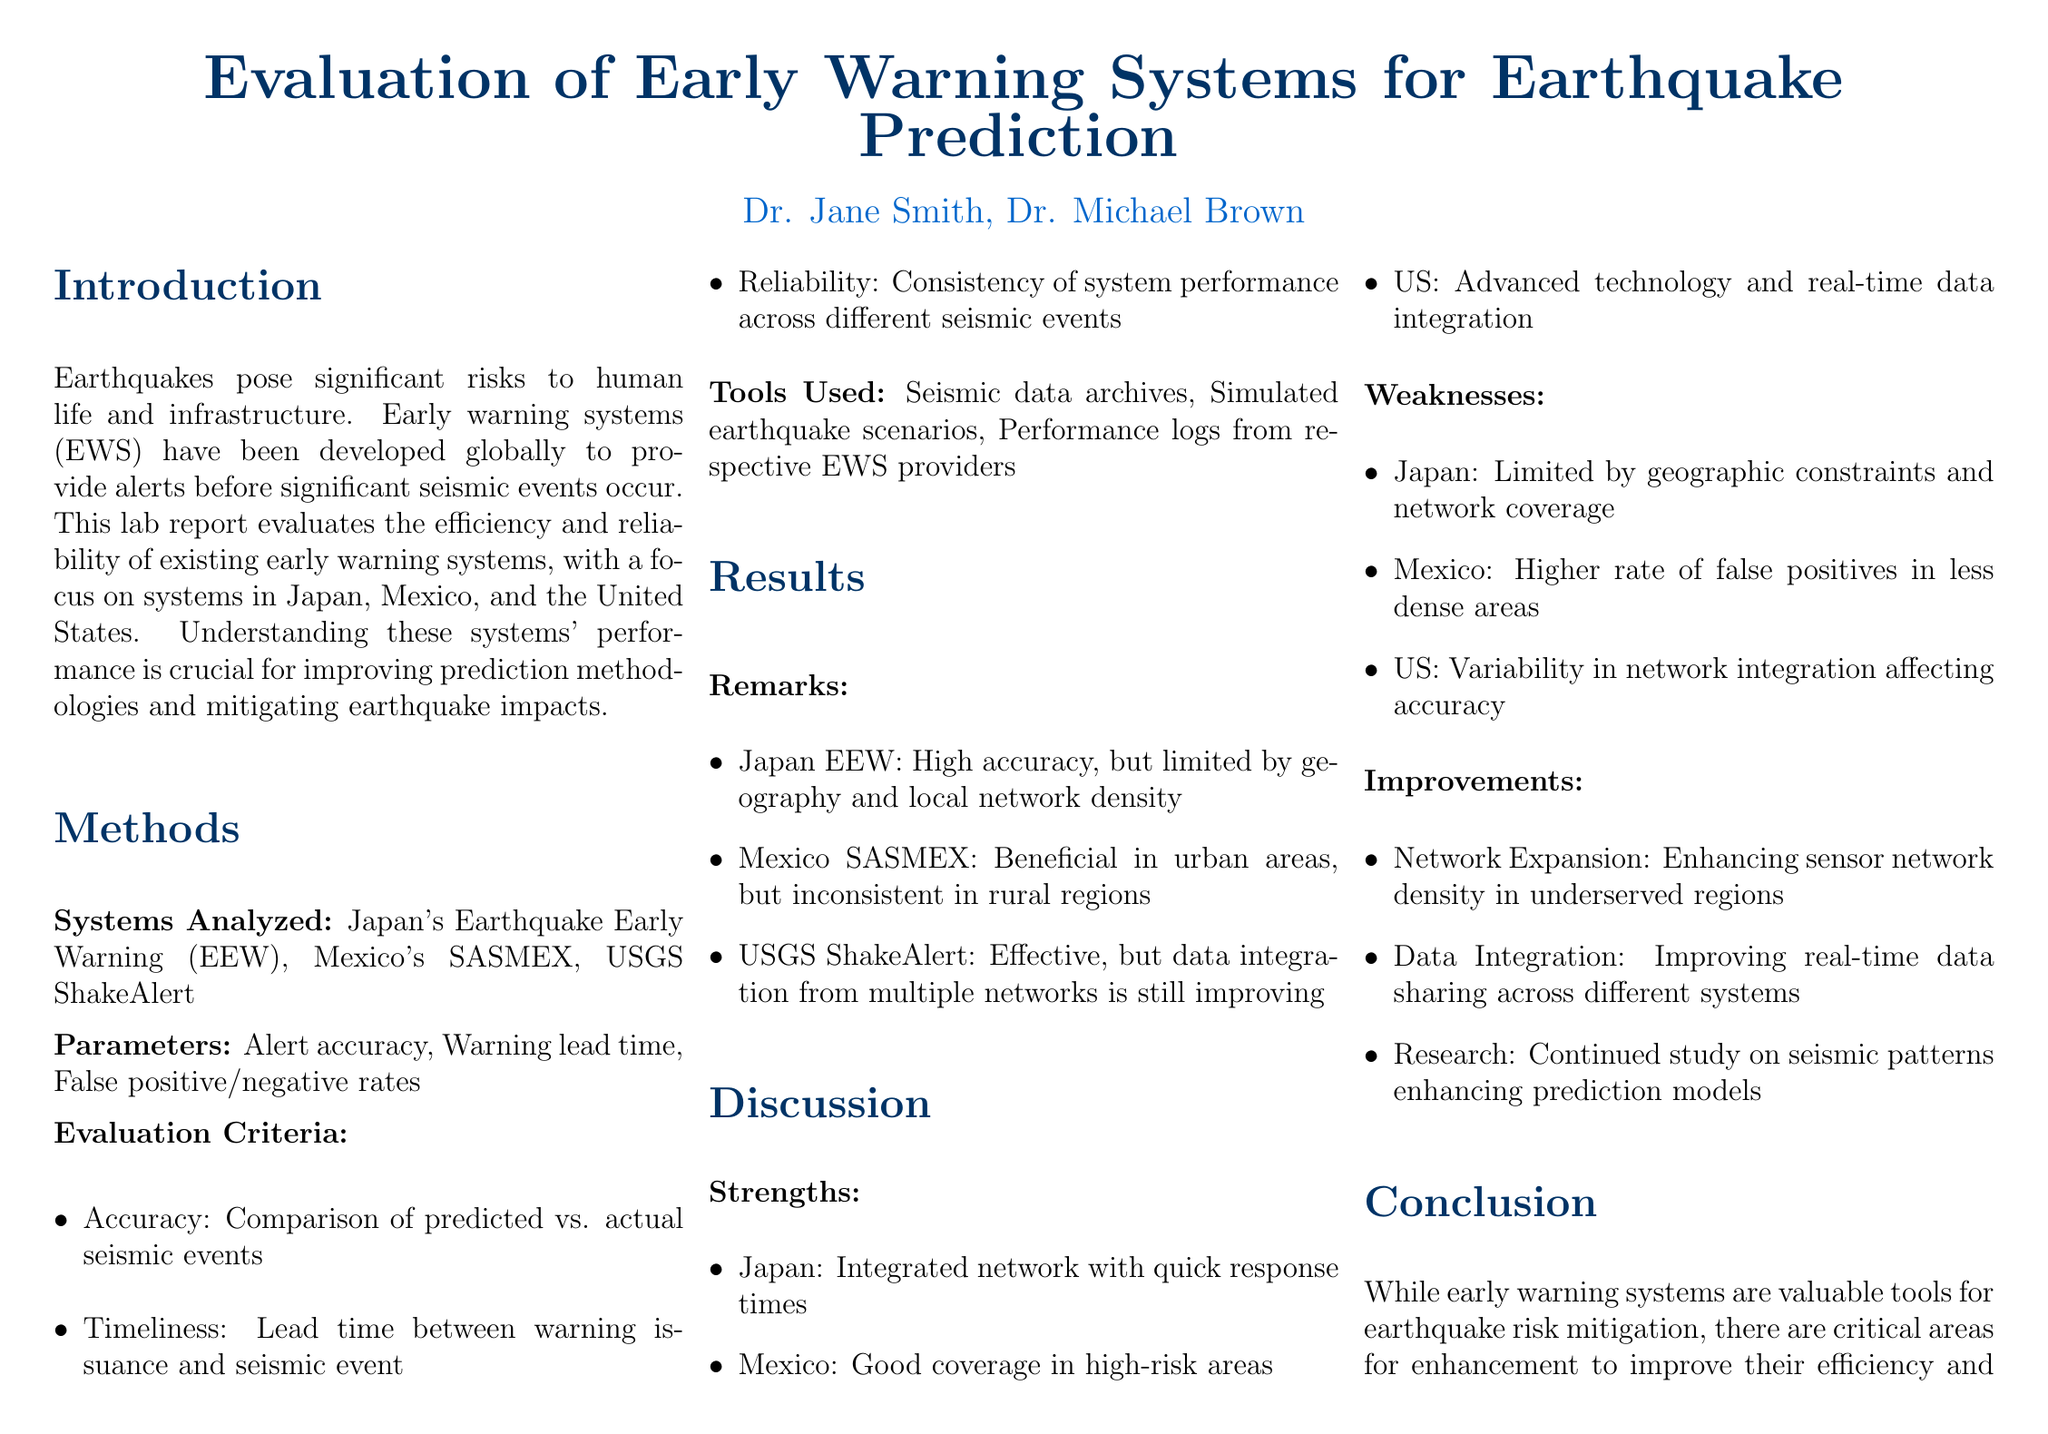What are the three early warning systems evaluated? The systems analyzed are Japan's Earthquake Early Warning, Mexico's SASMEX, and USGS ShakeAlert.
Answer: Japan's Earthquake Early Warning, Mexico's SASMEX, USGS ShakeAlert What is the average lead time for Japan's Earthquake Early Warning system? The table presents the average lead time for each system, with Japan's Earthquake Early Warning having an average lead time of 15 seconds.
Answer: 15 seconds What is the false positive rate for Mexico's SASMEX? The false positive rates for the systems are listed, and for Mexico's SASMEX, it is 10 percent.
Answer: 10 percent What is one strength of the US early warning system? The discussion section highlights the strengths of each system, noting that the US has advanced technology and real-time data integration.
Answer: Advanced technology and real-time data integration What improvement is suggested for enhancing the efficiency of early warning systems? The report mentions several improvements, one of which is enhancing sensor network density in underserved regions.
Answer: Network Expansion How does Japan's Earthquake Early Warning system's accuracy compare to the others? The results show that Japan's Earthquake Early Warning has the highest accuracy at 88 percent compared to the others, which are lower.
Answer: 88 percent What publication provides information on the ShakeAlert system? The references section lists the sources cited, with the U.S. Geological Survey providing information on the ShakeAlert system.
Answer: U.S. Geological Survey What is the key focus of this lab report? The introduction states the purpose of the report is to evaluate the efficiency and reliability of existing early warning systems.
Answer: Efficiency and reliability What is a weakness of the USGS ShakeAlert system? The report identifies variability in network integration affecting accuracy as a weakness of the USGS ShakeAlert system.
Answer: Variability in network integration 